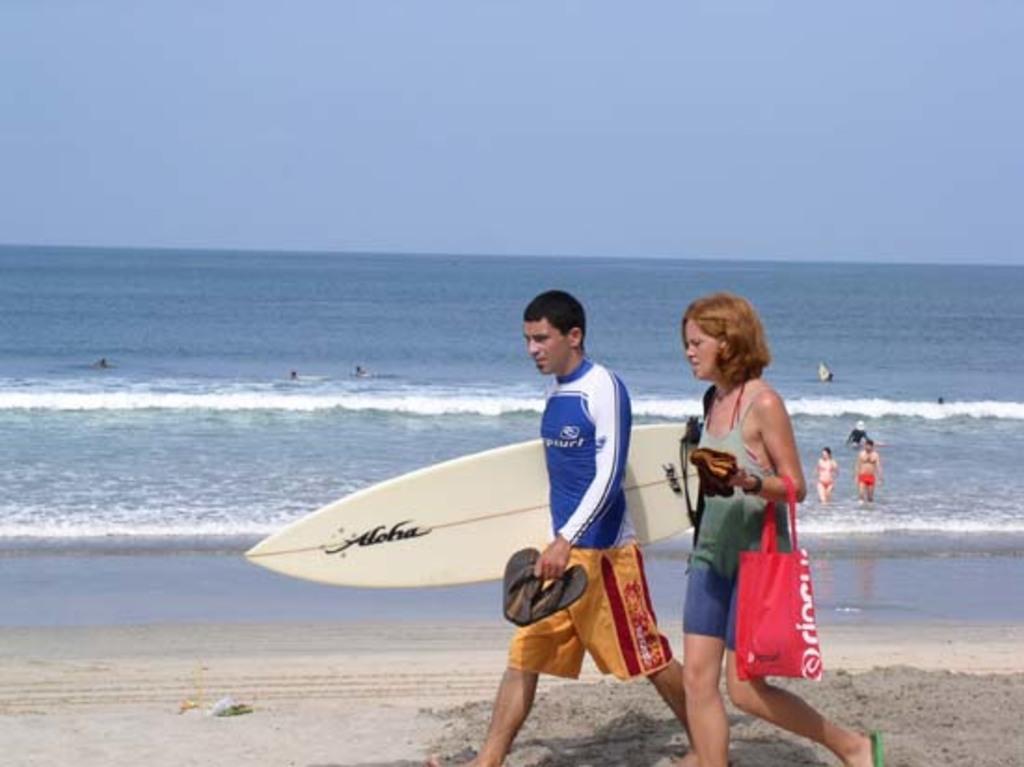In one or two sentences, can you explain what this image depicts? In this image there are two persons who are walking on the seashore a person at the middle of the image wearing blue color shirt holding surfing board and at the background there is an ocean. 